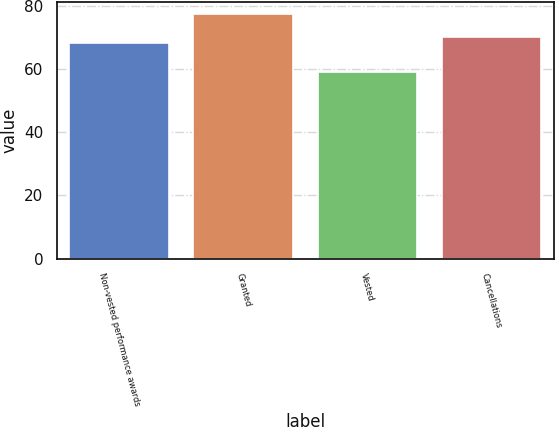<chart> <loc_0><loc_0><loc_500><loc_500><bar_chart><fcel>Non-vested performance awards<fcel>Granted<fcel>Vested<fcel>Cancellations<nl><fcel>68.13<fcel>77.33<fcel>58.94<fcel>69.97<nl></chart> 